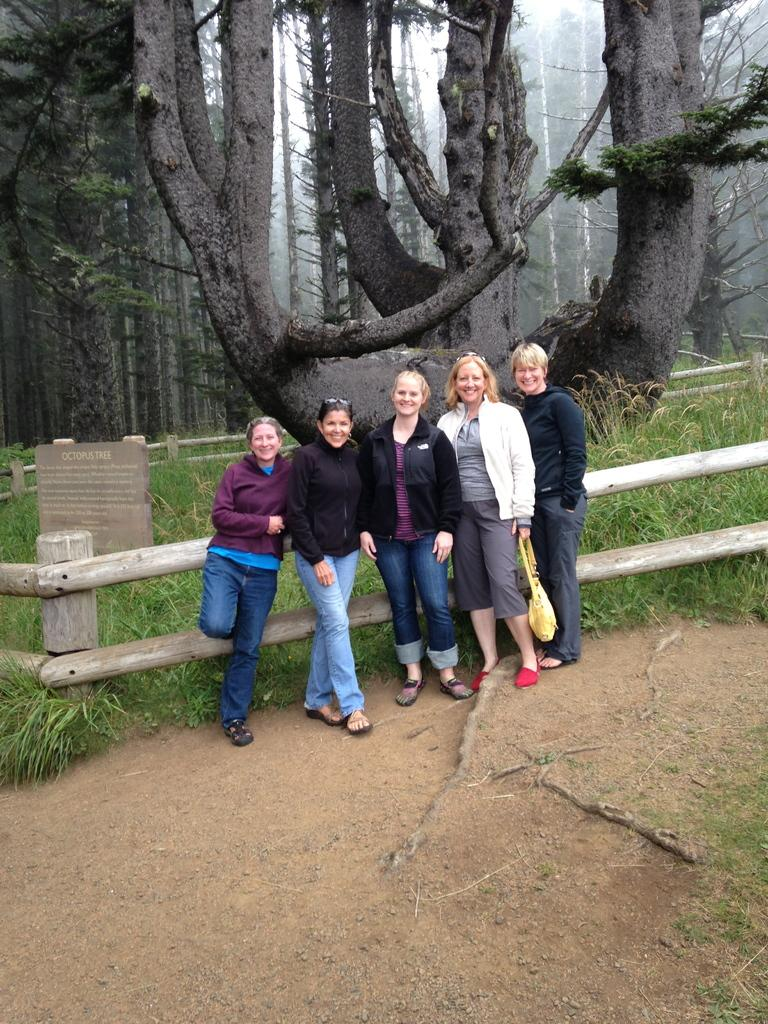What are the people in the image doing? The people in the image are standing in the center and smiling. What can be seen in the background of the image? There is a fence, a board, and trees in the background of the image. What type of cork can be seen floating in the water in the image? There is no water or cork present in the image; it features people standing and smiling with a background of a fence, board, and trees. 